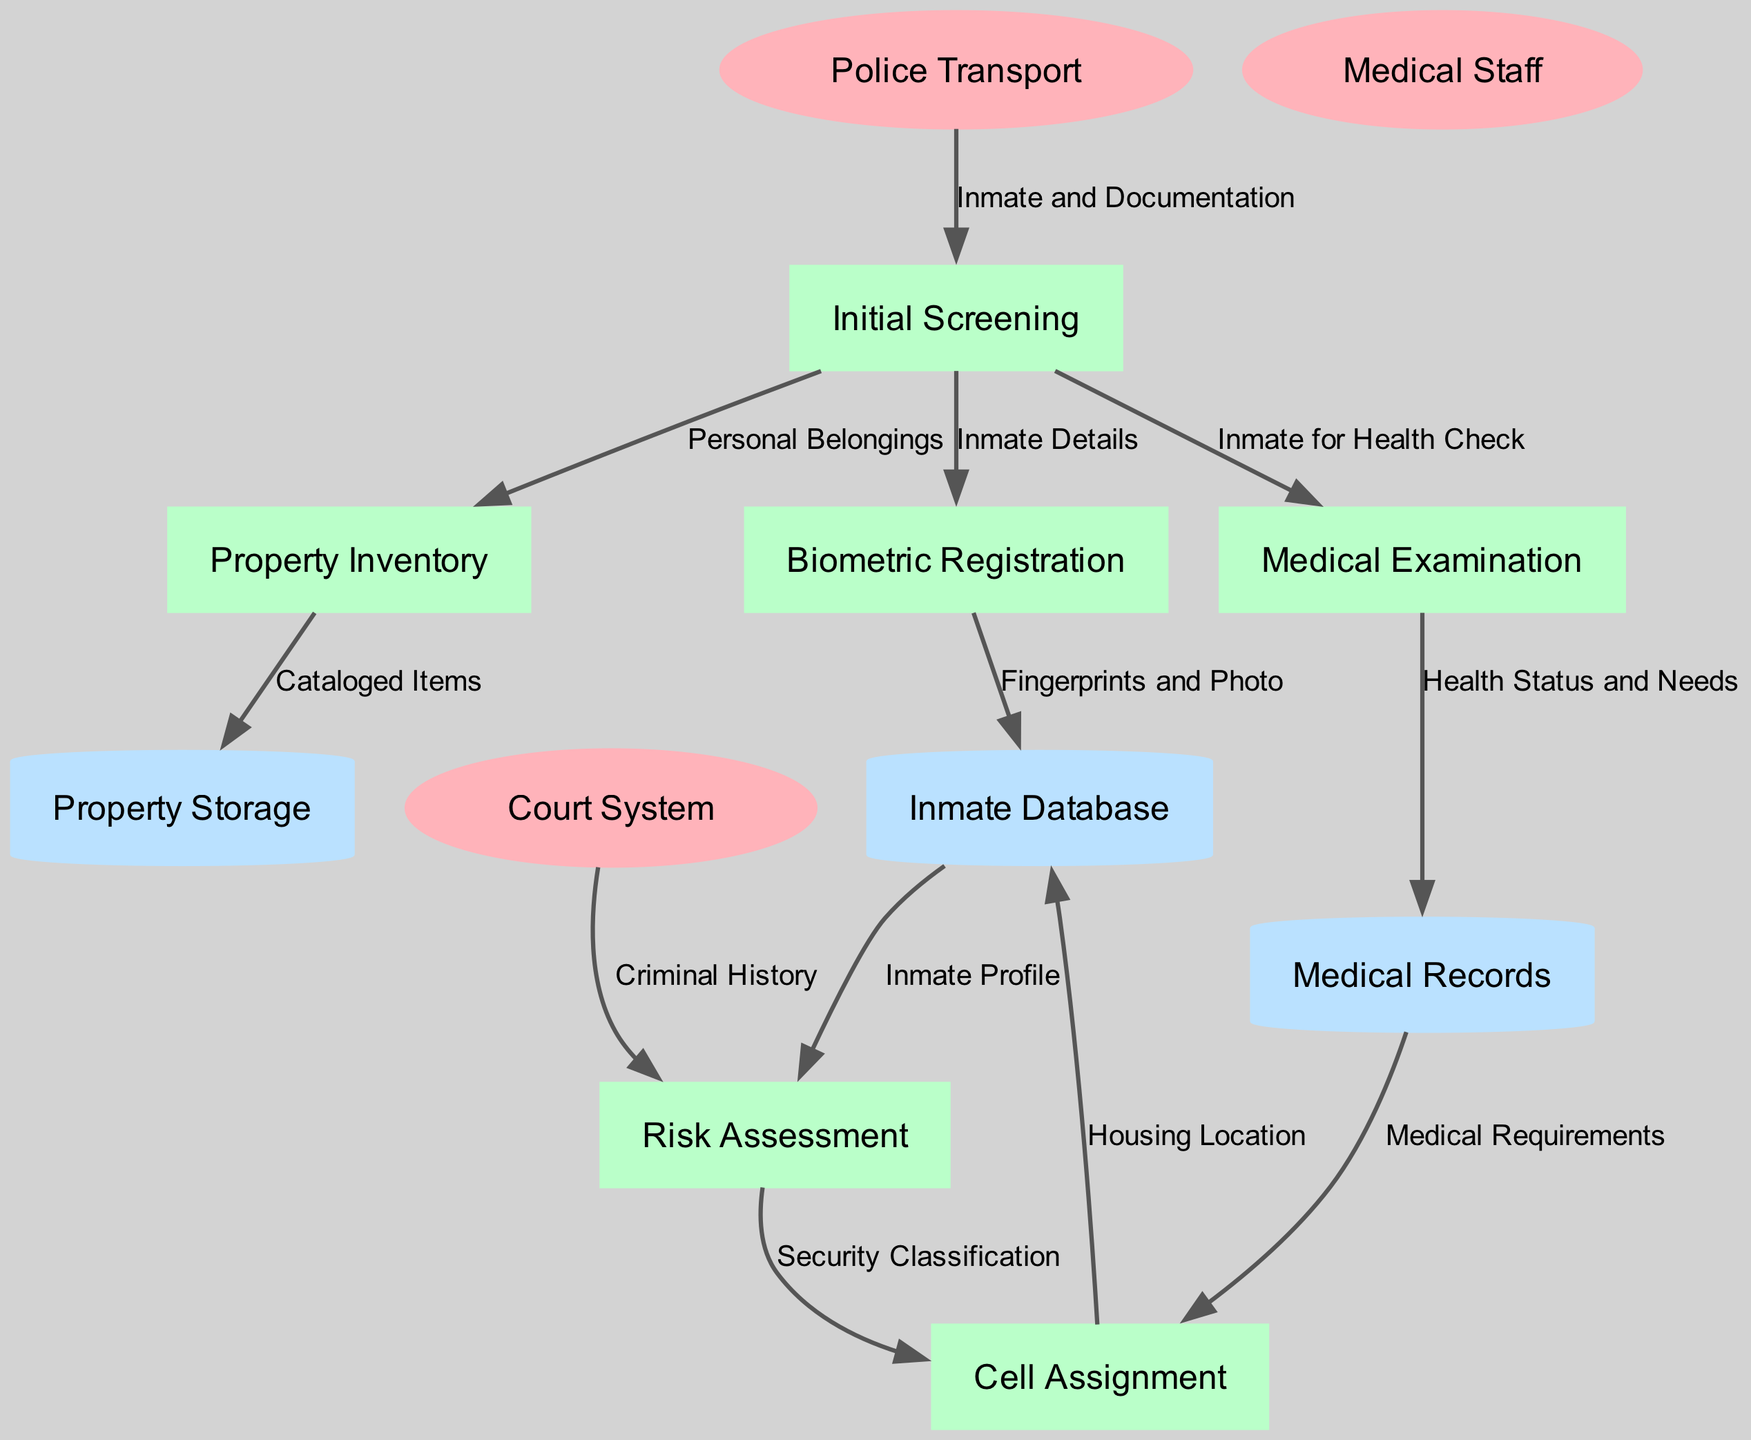What is the first process in the inmate intake process? The first process listed in the diagram is "Initial Screening," which is the starting point for the intake procedure before any further actions are taken.
Answer: Initial Screening How many external entities are represented in the diagram? There are three external entities shown in the diagram: Police Transport, Court System, and Medical Staff, which are denoted as ellipses.
Answer: 3 Which process receives "Inmate and Documentation" from Police Transport? The "Initial Screening" process receives "Inmate and Documentation" from the Police Transport as its first data flow, indicating the documentation required for intake.
Answer: Initial Screening What type of data store is "Property Storage"? "Property Storage" is represented as a cylinder in the diagram, which is the standard symbol for a data store, specifically used for storing inmate property.
Answer: Cylinder Which two processes provide inputs for "Cell Assignment"? The "Cell Assignment" process receives inputs from both "Risk Assessment" and "Medical Records," as indicated by the data flows leading into it.
Answer: Risk Assessment and Medical Records What data flows into "Biometric Registration"? The data flow into "Biometric Registration" comes from "Initial Screening," which sends inmate details necessary for creating biometric profiles.
Answer: Inmate Details What is recorded in the "Inmate Database" from "Biometric Registration"? From "Biometric Registration," the data flow labeled "Fingerprints and Photo" indicates that biometric data is added to the "Inmate Database."
Answer: Fingerprints and Photo How does the "Risk Assessment" process obtain an "Inmate Profile"? The "Risk Assessment" process obtains the "Inmate Profile" from the "Inmate Database," combining the biometric registration data with criminal history from the Court System.
Answer: Inmate Database What label indicates the connection between "Property Inventory" and "Property Storage"? The label "Cataloged Items" indicates the connection where cataloged personal belongings are sent from "Property Inventory" to "Property Storage."
Answer: Cataloged Items 